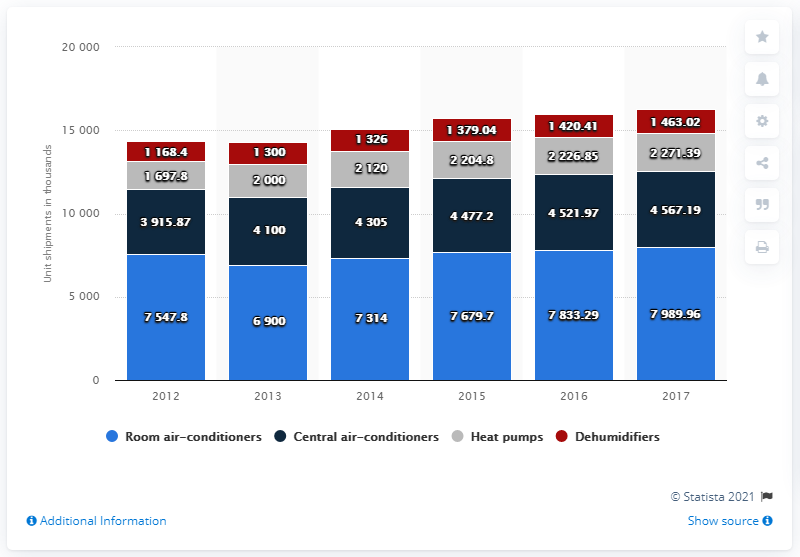Specify some key components in this picture. In 2017, the value of the gray bar was 2271.39. The sum of all the bars in 2012 is 14329.87. 